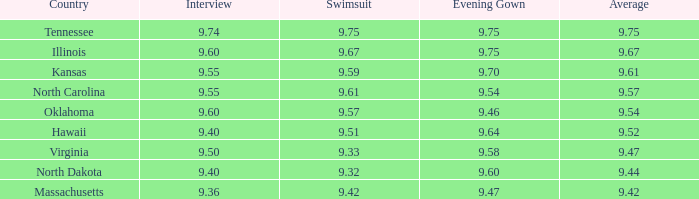40 and mean of North Dakota. 